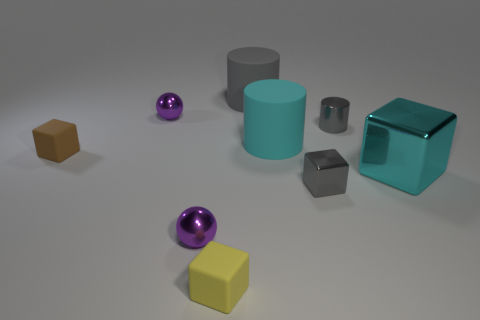Add 1 small purple metallic balls. How many objects exist? 10 Subtract all balls. How many objects are left? 7 Subtract all blue metallic cylinders. Subtract all big metal objects. How many objects are left? 8 Add 8 big gray matte things. How many big gray matte things are left? 9 Add 6 large things. How many large things exist? 9 Subtract 0 cyan spheres. How many objects are left? 9 